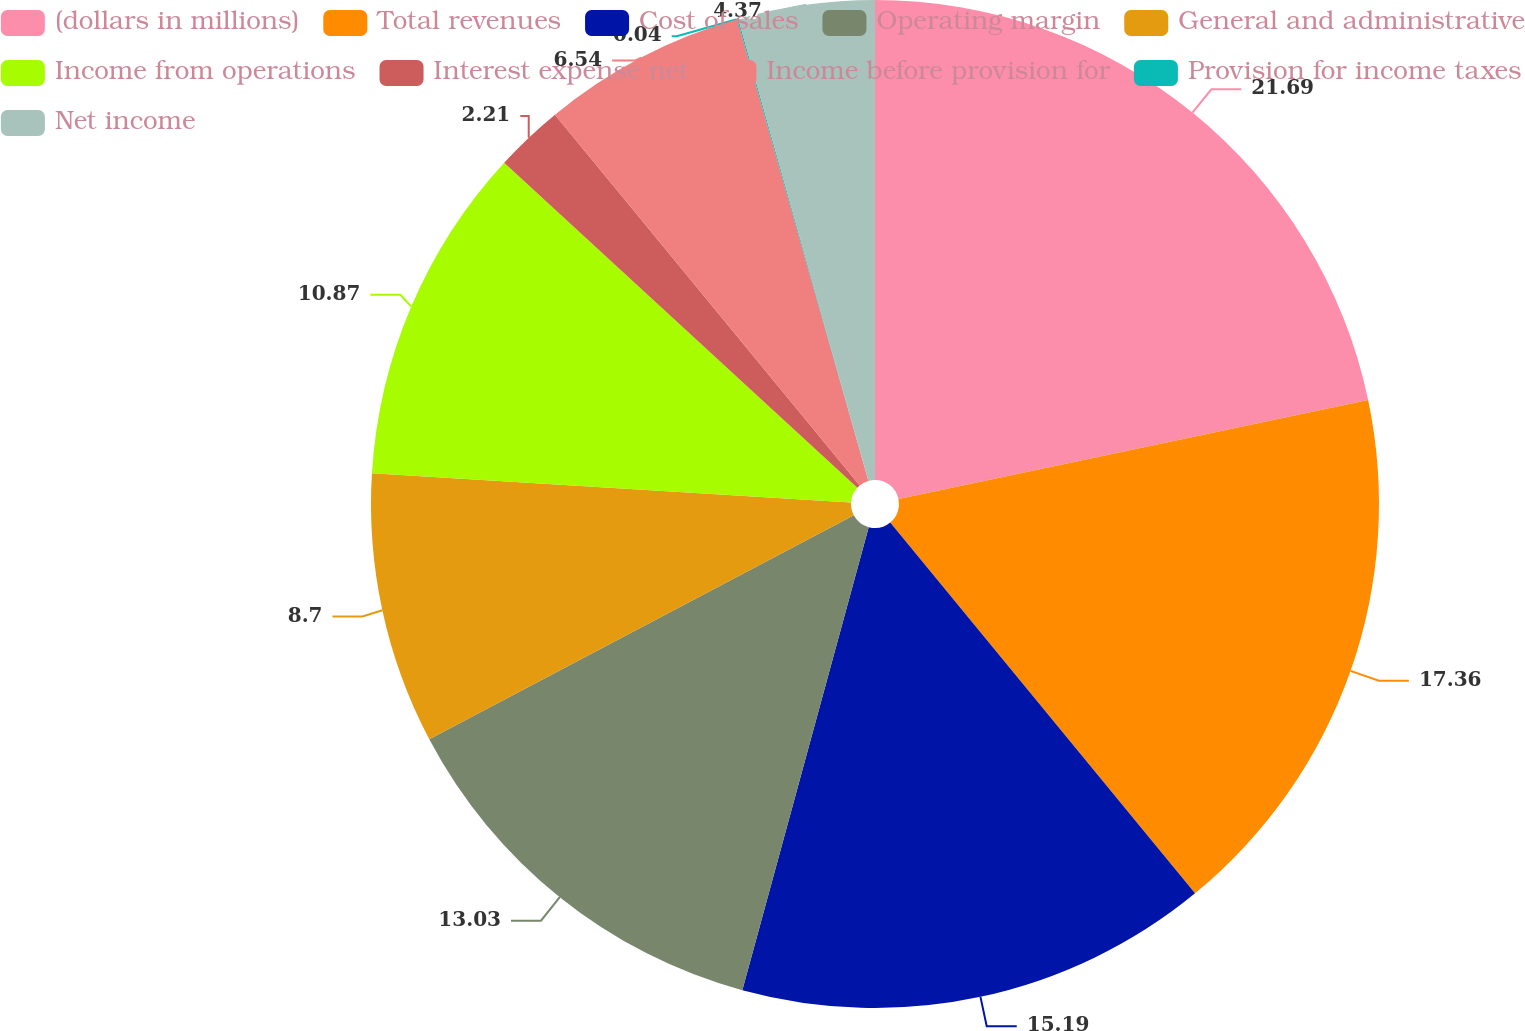<chart> <loc_0><loc_0><loc_500><loc_500><pie_chart><fcel>(dollars in millions)<fcel>Total revenues<fcel>Cost of sales<fcel>Operating margin<fcel>General and administrative<fcel>Income from operations<fcel>Interest expense net<fcel>Income before provision for<fcel>Provision for income taxes<fcel>Net income<nl><fcel>21.69%<fcel>17.36%<fcel>15.19%<fcel>13.03%<fcel>8.7%<fcel>10.87%<fcel>2.21%<fcel>6.54%<fcel>0.04%<fcel>4.37%<nl></chart> 